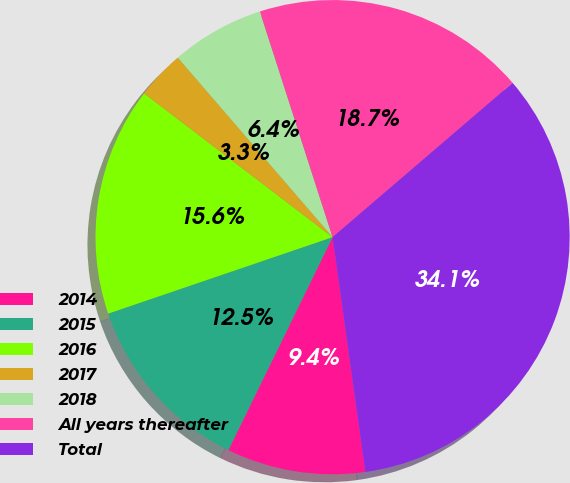Convert chart. <chart><loc_0><loc_0><loc_500><loc_500><pie_chart><fcel>2014<fcel>2015<fcel>2016<fcel>2017<fcel>2018<fcel>All years thereafter<fcel>Total<nl><fcel>9.45%<fcel>12.53%<fcel>15.6%<fcel>3.3%<fcel>6.37%<fcel>18.68%<fcel>34.07%<nl></chart> 